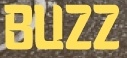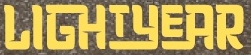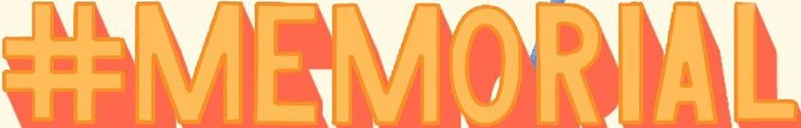Transcribe the words shown in these images in order, separated by a semicolon. BUZZ; LIGHTYEAR; #MEMORIAL 